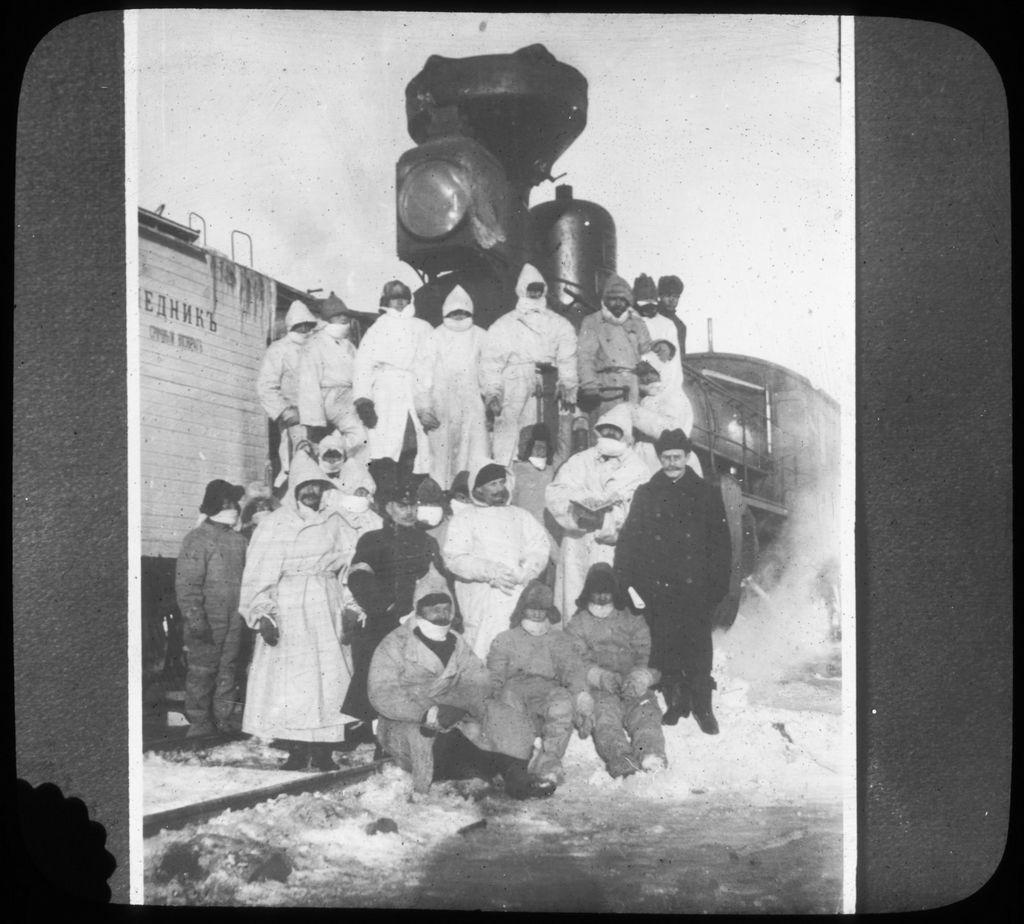Could you give a brief overview of what you see in this image? In this image we can see people standing and sitting. In the center there is a train and we can see people standing on the train. On the left there is a vehicle. At the top there is sky. 